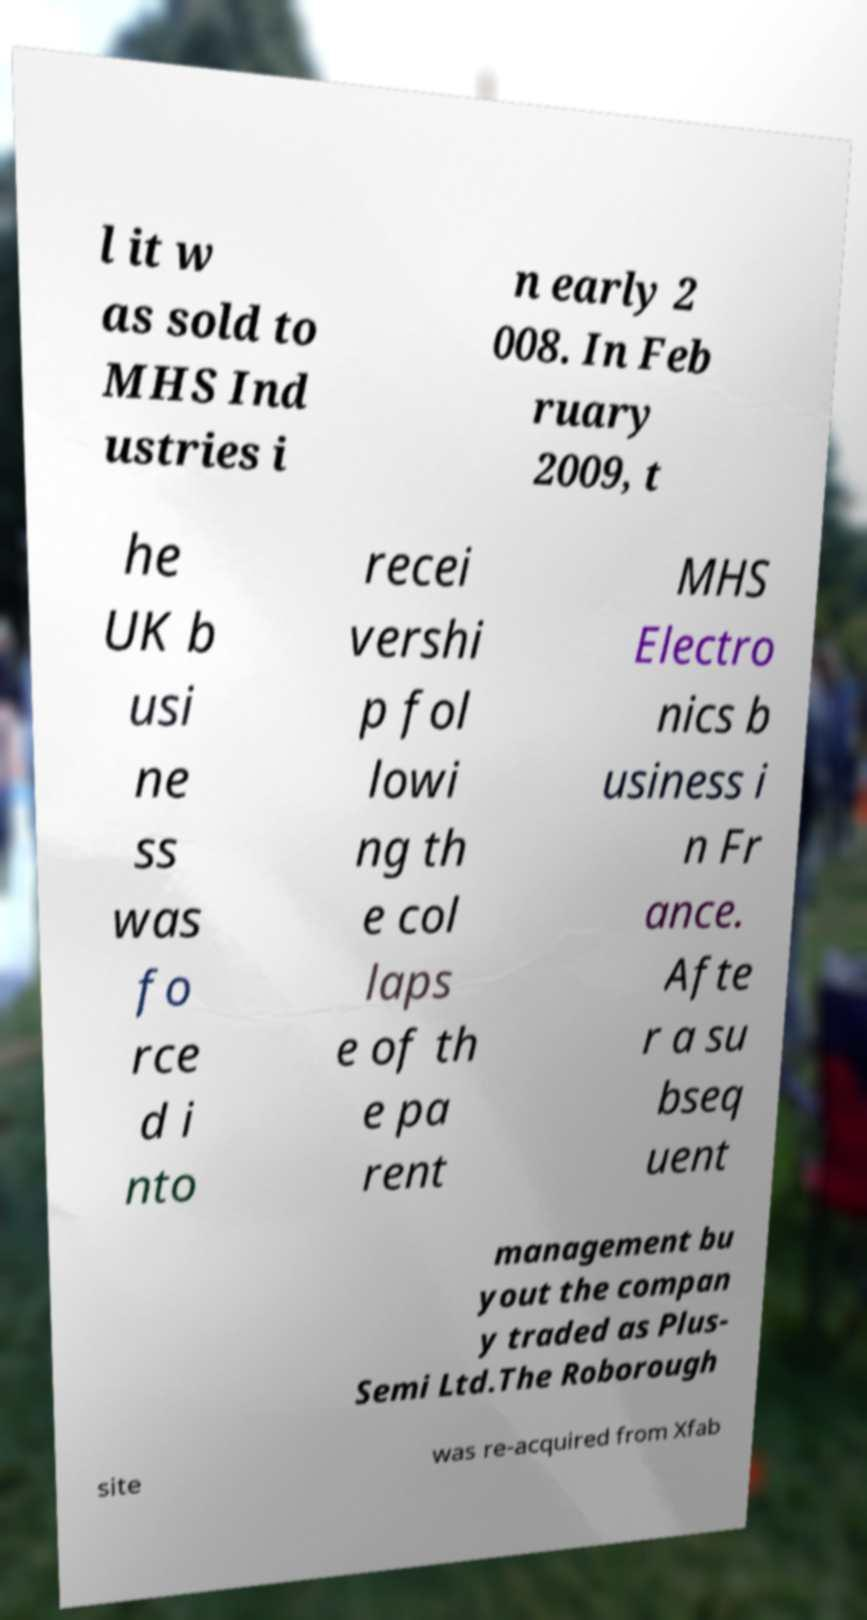Please read and relay the text visible in this image. What does it say? l it w as sold to MHS Ind ustries i n early 2 008. In Feb ruary 2009, t he UK b usi ne ss was fo rce d i nto recei vershi p fol lowi ng th e col laps e of th e pa rent MHS Electro nics b usiness i n Fr ance. Afte r a su bseq uent management bu yout the compan y traded as Plus- Semi Ltd.The Roborough site was re-acquired from Xfab 